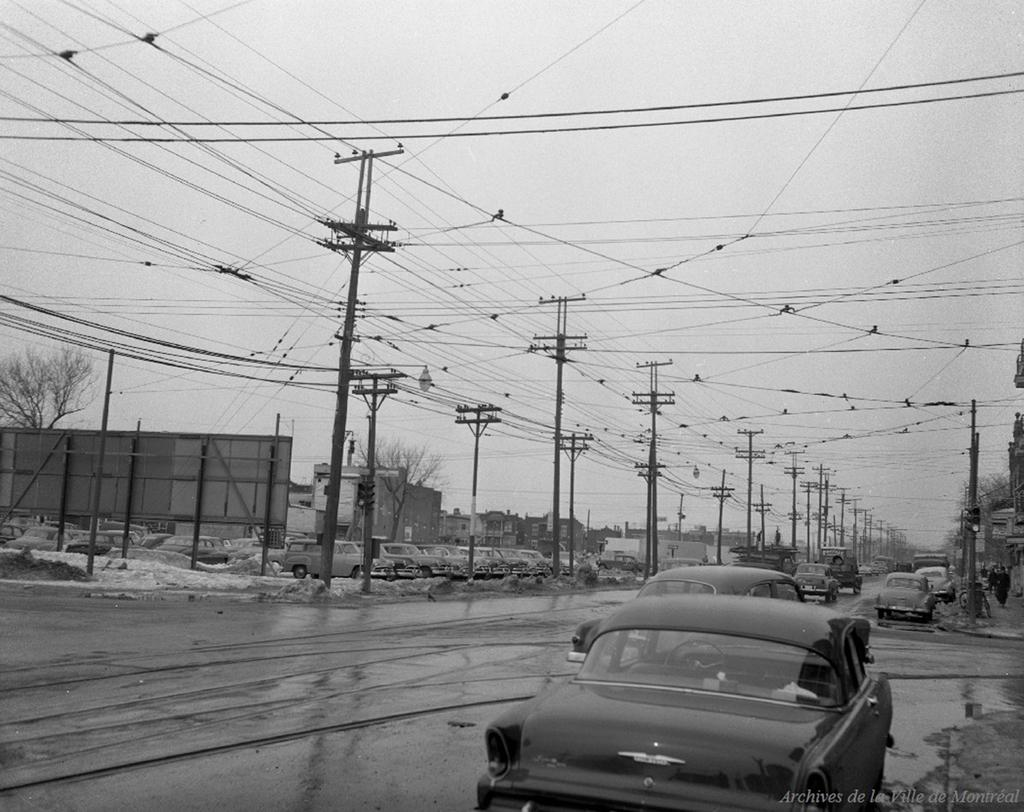What can be seen on the road in the image? There are vehicles on the road in the image. What is visible in the background of the image? Electric poles, buildings, and trees can be seen in the background of the image. What is the color scheme of the image? The image is in black and white. What type of steel is used to construct the buildings in the image? There is no information about the type of steel used in the construction of the buildings in the image. Can you tell me how many members are on the team in the image? There is no team present in the image. 